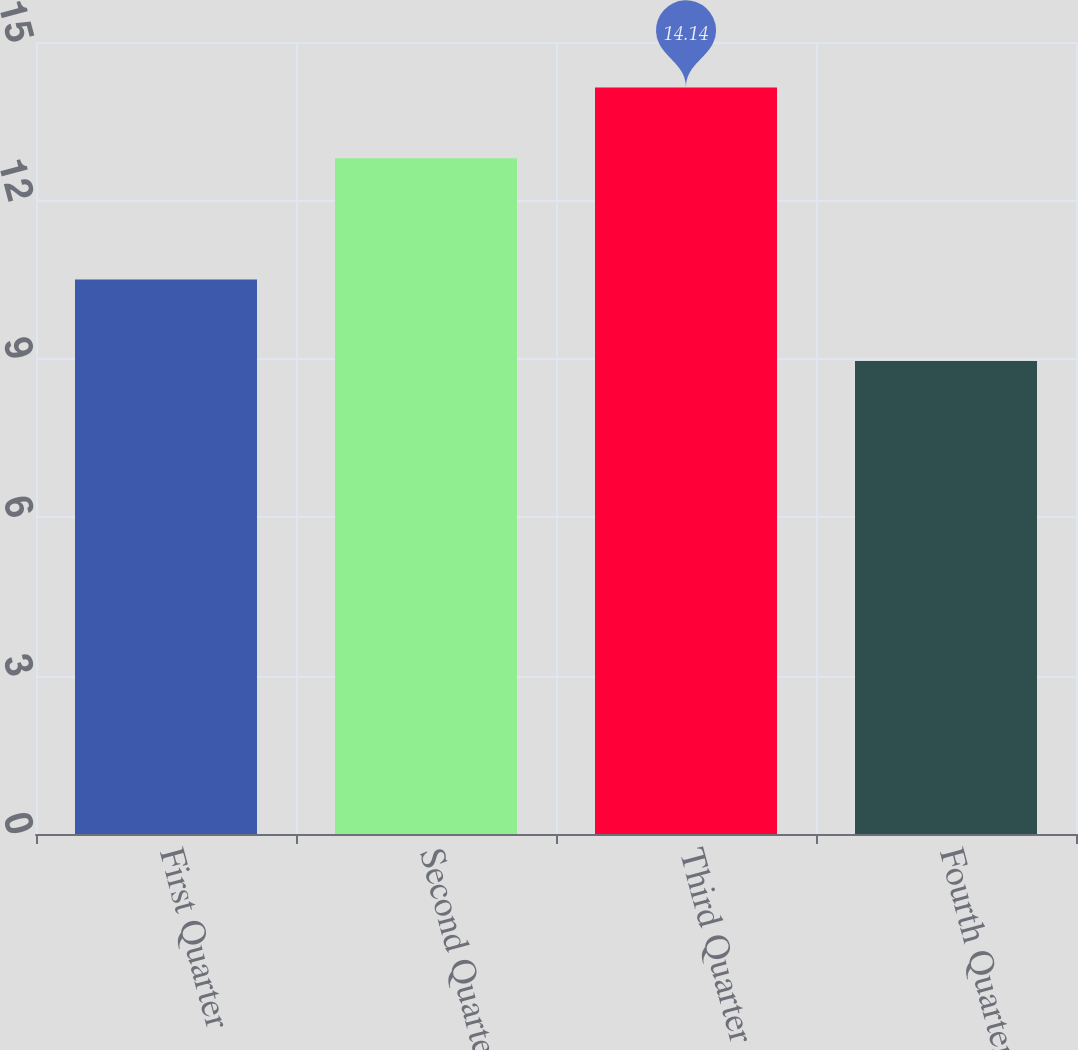Convert chart to OTSL. <chart><loc_0><loc_0><loc_500><loc_500><bar_chart><fcel>First Quarter<fcel>Second Quarter<fcel>Third Quarter<fcel>Fourth Quarter<nl><fcel>10.5<fcel>12.8<fcel>14.14<fcel>8.96<nl></chart> 